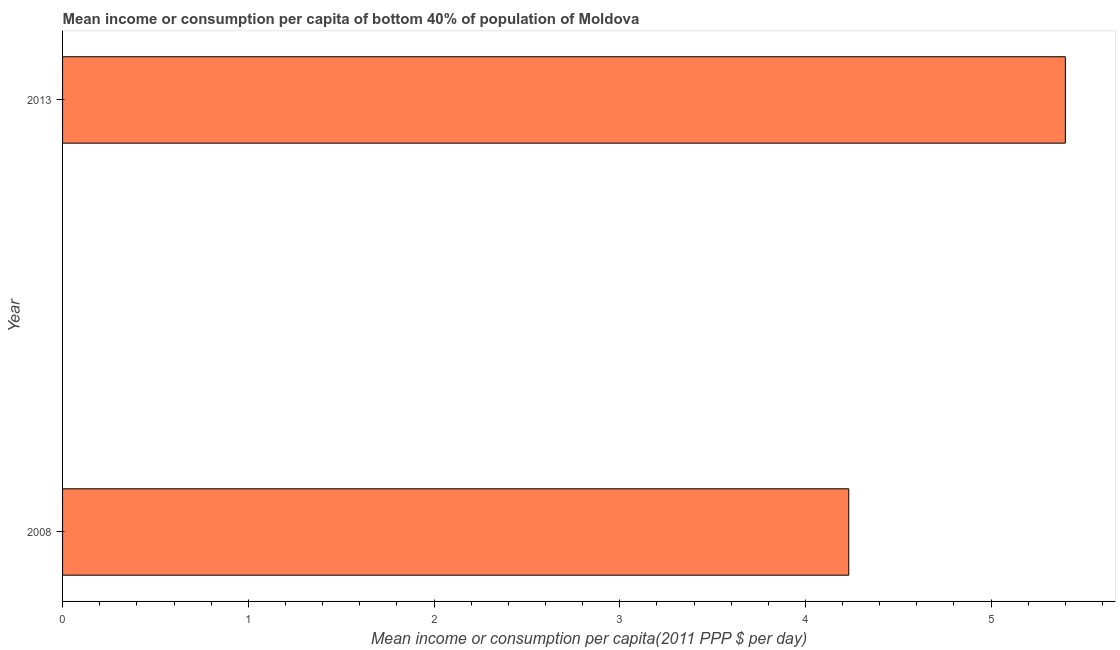Does the graph contain grids?
Provide a short and direct response. No. What is the title of the graph?
Provide a succinct answer. Mean income or consumption per capita of bottom 40% of population of Moldova. What is the label or title of the X-axis?
Offer a terse response. Mean income or consumption per capita(2011 PPP $ per day). What is the mean income or consumption in 2008?
Make the answer very short. 4.23. Across all years, what is the maximum mean income or consumption?
Your answer should be very brief. 5.4. Across all years, what is the minimum mean income or consumption?
Your answer should be compact. 4.23. What is the sum of the mean income or consumption?
Give a very brief answer. 9.63. What is the difference between the mean income or consumption in 2008 and 2013?
Keep it short and to the point. -1.17. What is the average mean income or consumption per year?
Ensure brevity in your answer.  4.82. What is the median mean income or consumption?
Give a very brief answer. 4.82. What is the ratio of the mean income or consumption in 2008 to that in 2013?
Ensure brevity in your answer.  0.78. Is the mean income or consumption in 2008 less than that in 2013?
Your response must be concise. Yes. In how many years, is the mean income or consumption greater than the average mean income or consumption taken over all years?
Make the answer very short. 1. What is the difference between two consecutive major ticks on the X-axis?
Provide a succinct answer. 1. Are the values on the major ticks of X-axis written in scientific E-notation?
Your response must be concise. No. What is the Mean income or consumption per capita(2011 PPP $ per day) of 2008?
Provide a succinct answer. 4.23. What is the Mean income or consumption per capita(2011 PPP $ per day) in 2013?
Keep it short and to the point. 5.4. What is the difference between the Mean income or consumption per capita(2011 PPP $ per day) in 2008 and 2013?
Your response must be concise. -1.17. What is the ratio of the Mean income or consumption per capita(2011 PPP $ per day) in 2008 to that in 2013?
Your response must be concise. 0.78. 